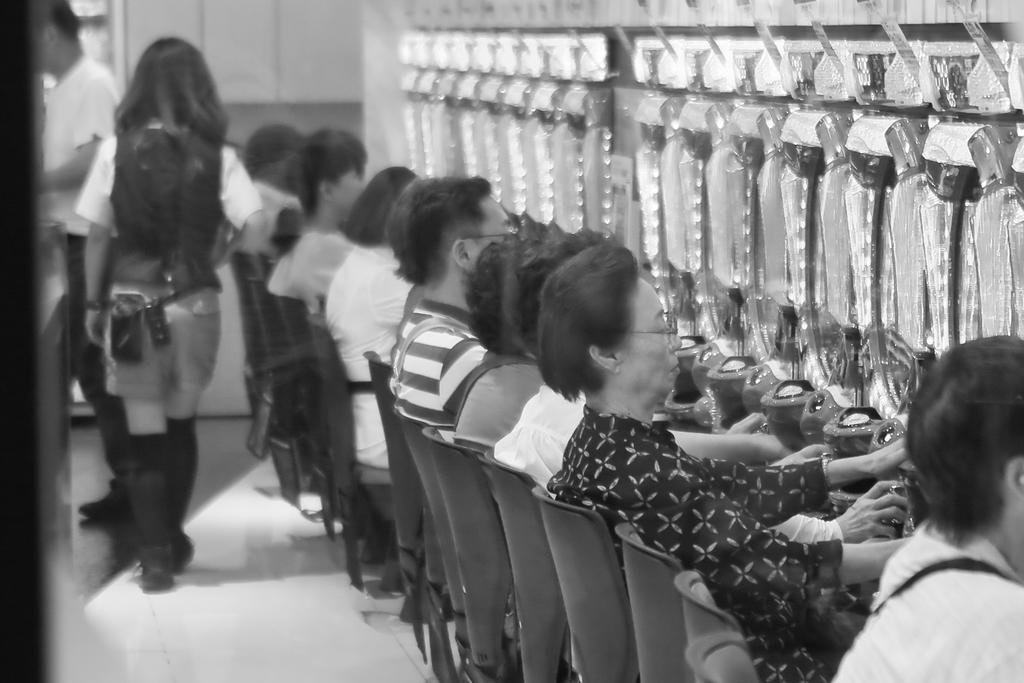Describe this image in one or two sentences. This is a black and white image. Here I can see few people are sitting on the chairs facing towards the right side. In front of these people there are few objects. On the left side there is a woman walking towards the back side and a man is standing facing towards the left side. In the background there is a wall. 